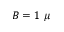Convert formula to latex. <formula><loc_0><loc_0><loc_500><loc_500>B = 1 \mu</formula> 